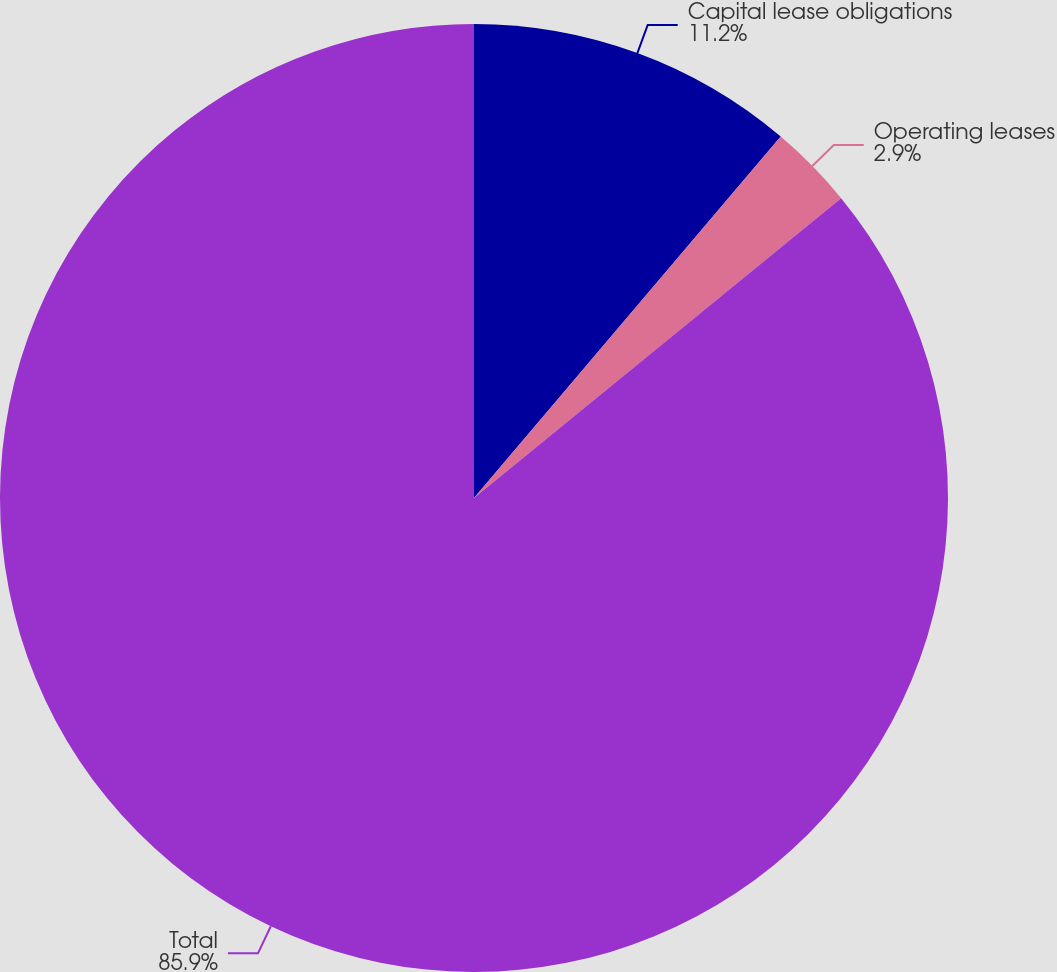<chart> <loc_0><loc_0><loc_500><loc_500><pie_chart><fcel>Capital lease obligations<fcel>Operating leases<fcel>Total<nl><fcel>11.2%<fcel>2.9%<fcel>85.89%<nl></chart> 